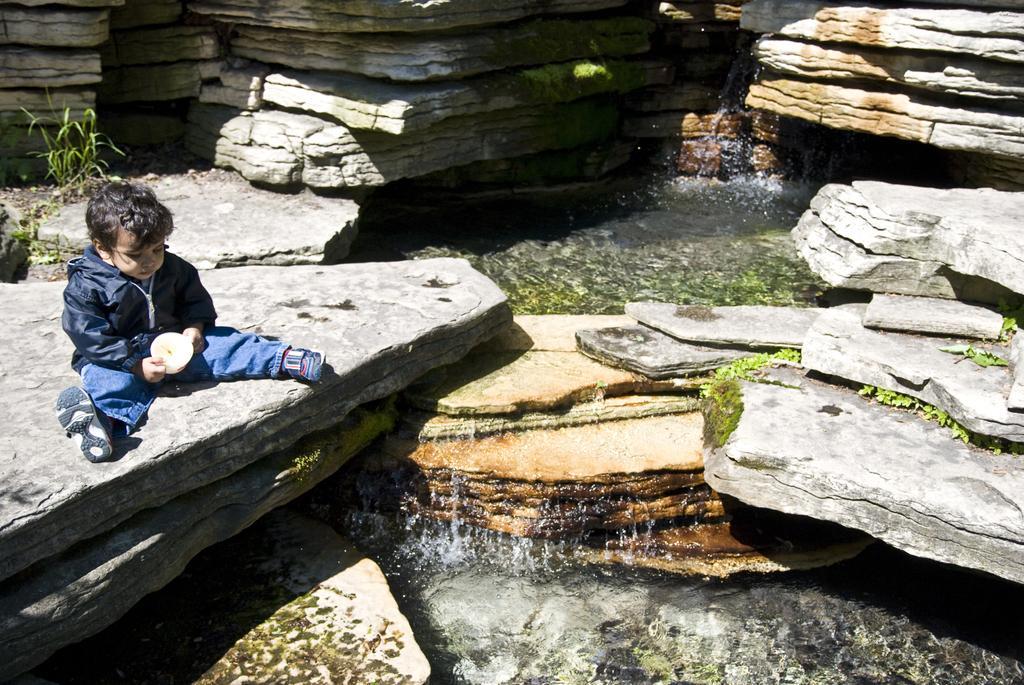How would you summarize this image in a sentence or two? In the image there is a kid in black jacket sitting on stone in front of waterfall. 